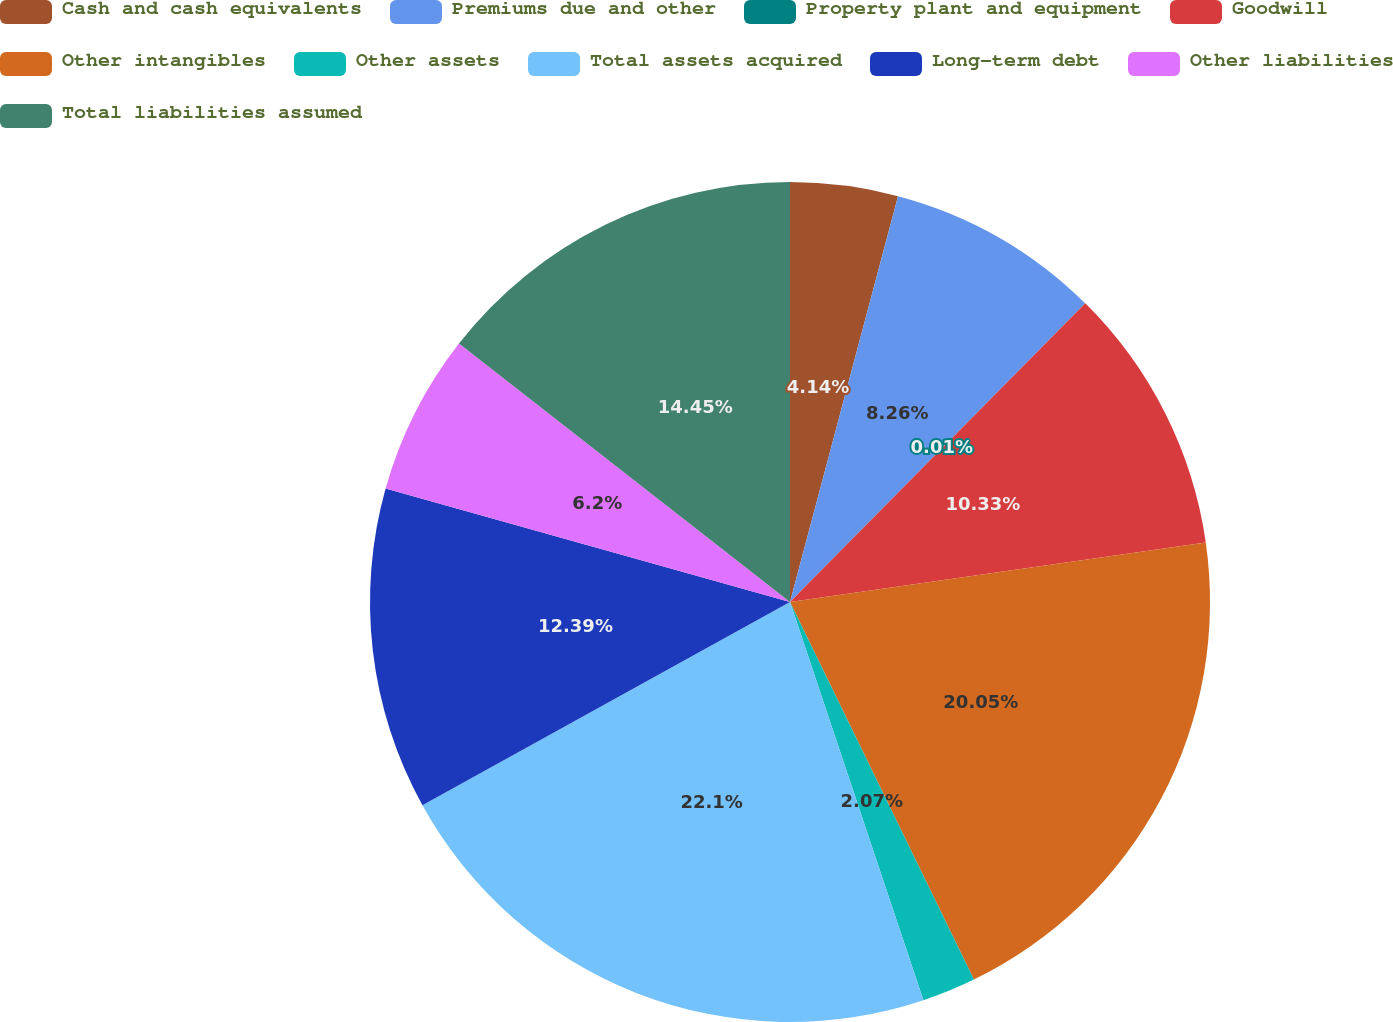Convert chart. <chart><loc_0><loc_0><loc_500><loc_500><pie_chart><fcel>Cash and cash equivalents<fcel>Premiums due and other<fcel>Property plant and equipment<fcel>Goodwill<fcel>Other intangibles<fcel>Other assets<fcel>Total assets acquired<fcel>Long-term debt<fcel>Other liabilities<fcel>Total liabilities assumed<nl><fcel>4.14%<fcel>8.26%<fcel>0.01%<fcel>10.33%<fcel>20.05%<fcel>2.07%<fcel>22.11%<fcel>12.39%<fcel>6.2%<fcel>14.45%<nl></chart> 